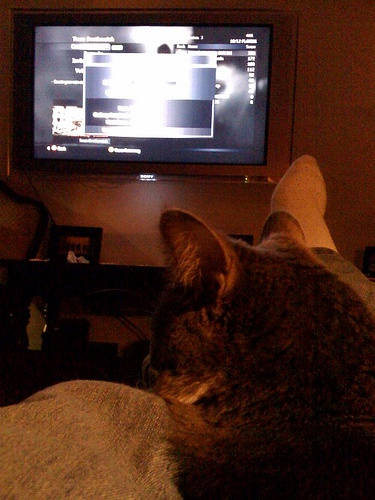Describe the objects in this image and their specific colors. I can see cat in maroon, black, and brown tones, tv in maroon, black, white, gray, and darkgray tones, and people in maroon and brown tones in this image. 